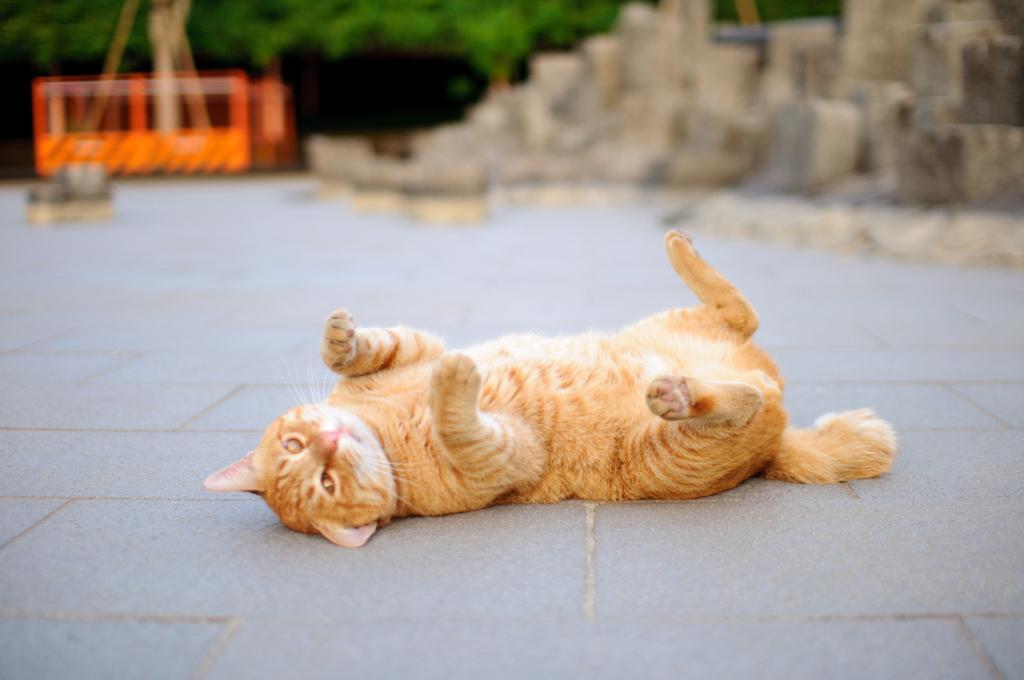Please provide a concise description of this image. In this image in the center there is one cat, at the bottom there is floor. In the background there are some trees, and some other objects. 